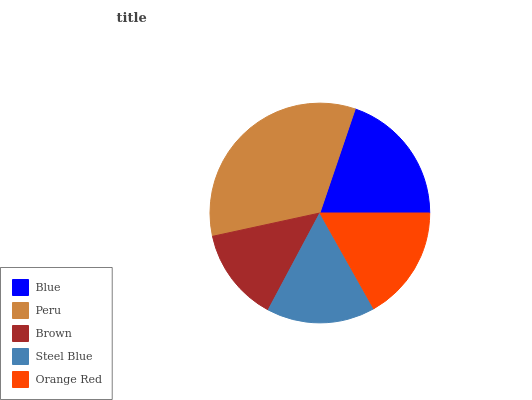Is Brown the minimum?
Answer yes or no. Yes. Is Peru the maximum?
Answer yes or no. Yes. Is Peru the minimum?
Answer yes or no. No. Is Brown the maximum?
Answer yes or no. No. Is Peru greater than Brown?
Answer yes or no. Yes. Is Brown less than Peru?
Answer yes or no. Yes. Is Brown greater than Peru?
Answer yes or no. No. Is Peru less than Brown?
Answer yes or no. No. Is Orange Red the high median?
Answer yes or no. Yes. Is Orange Red the low median?
Answer yes or no. Yes. Is Blue the high median?
Answer yes or no. No. Is Blue the low median?
Answer yes or no. No. 